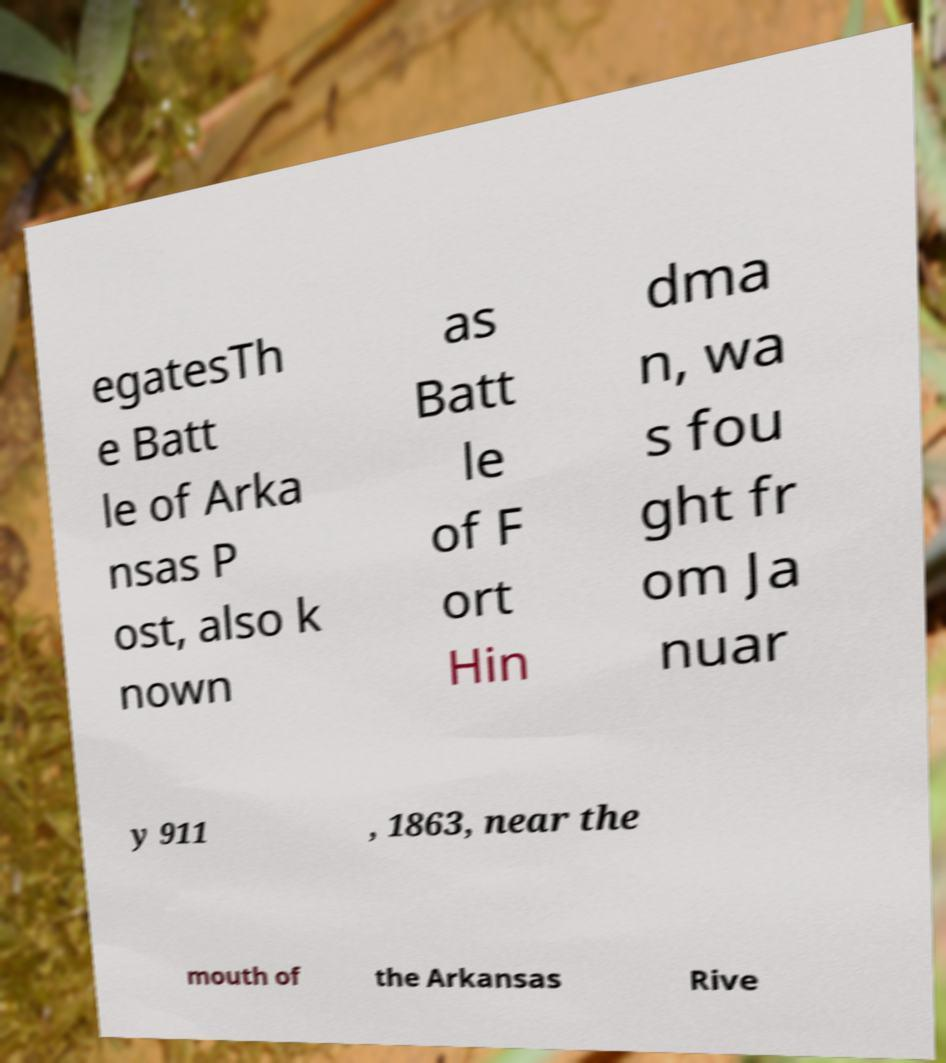For documentation purposes, I need the text within this image transcribed. Could you provide that? egatesTh e Batt le of Arka nsas P ost, also k nown as Batt le of F ort Hin dma n, wa s fou ght fr om Ja nuar y 911 , 1863, near the mouth of the Arkansas Rive 